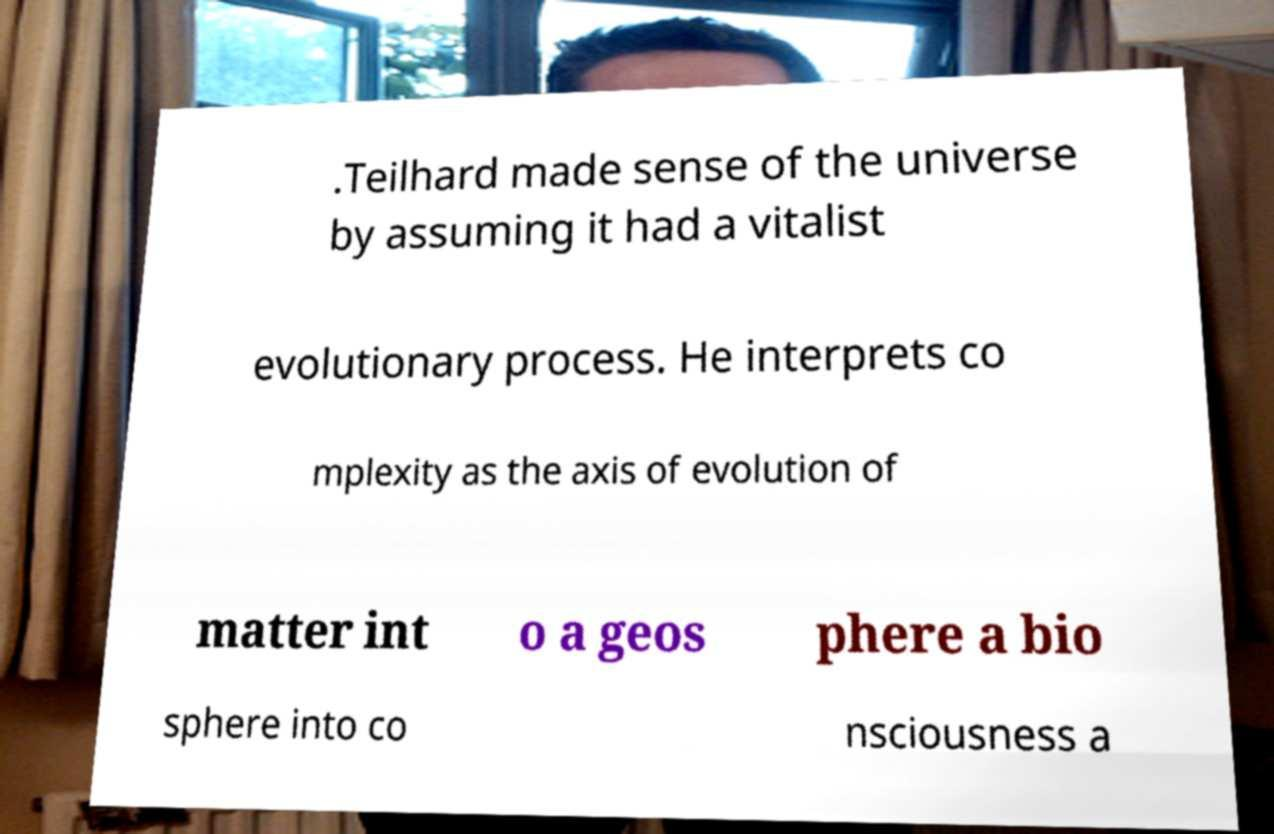What messages or text are displayed in this image? I need them in a readable, typed format. .Teilhard made sense of the universe by assuming it had a vitalist evolutionary process. He interprets co mplexity as the axis of evolution of matter int o a geos phere a bio sphere into co nsciousness a 